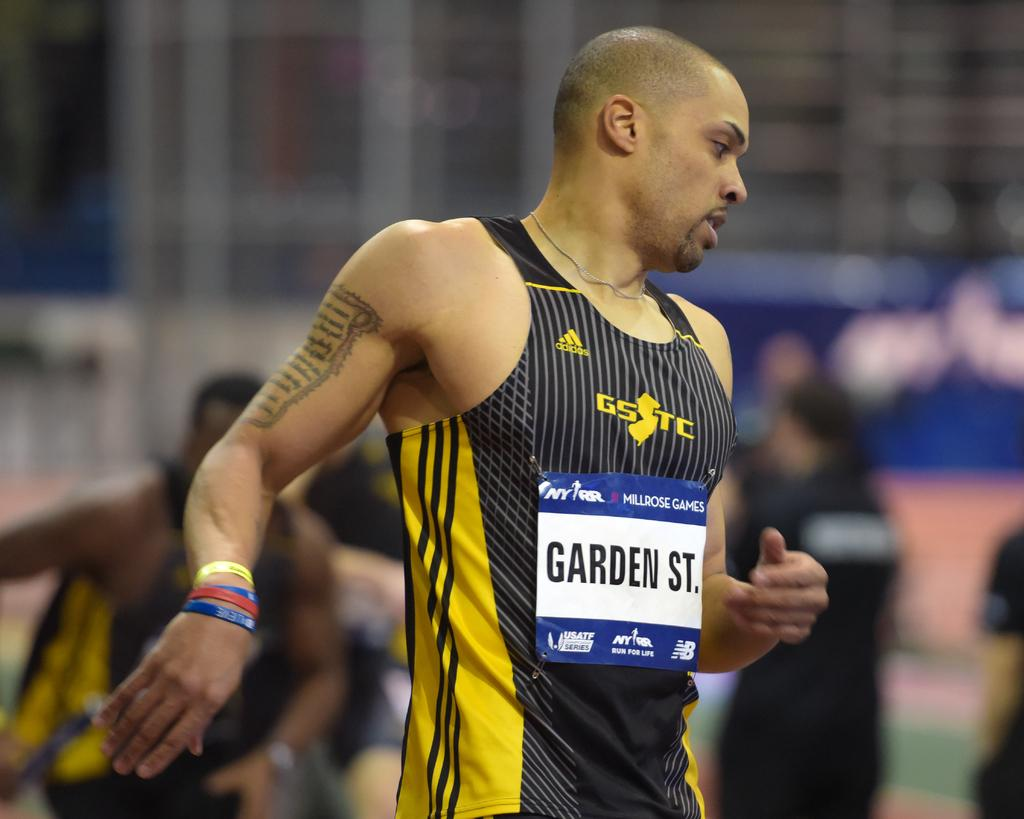Provide a one-sentence caption for the provided image. An athlete with "Garden St." on his tank top. 